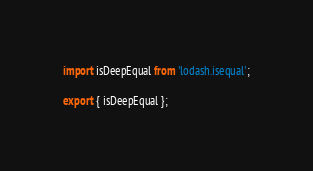<code> <loc_0><loc_0><loc_500><loc_500><_TypeScript_>import isDeepEqual from 'lodash.isequal';

export { isDeepEqual };
</code> 